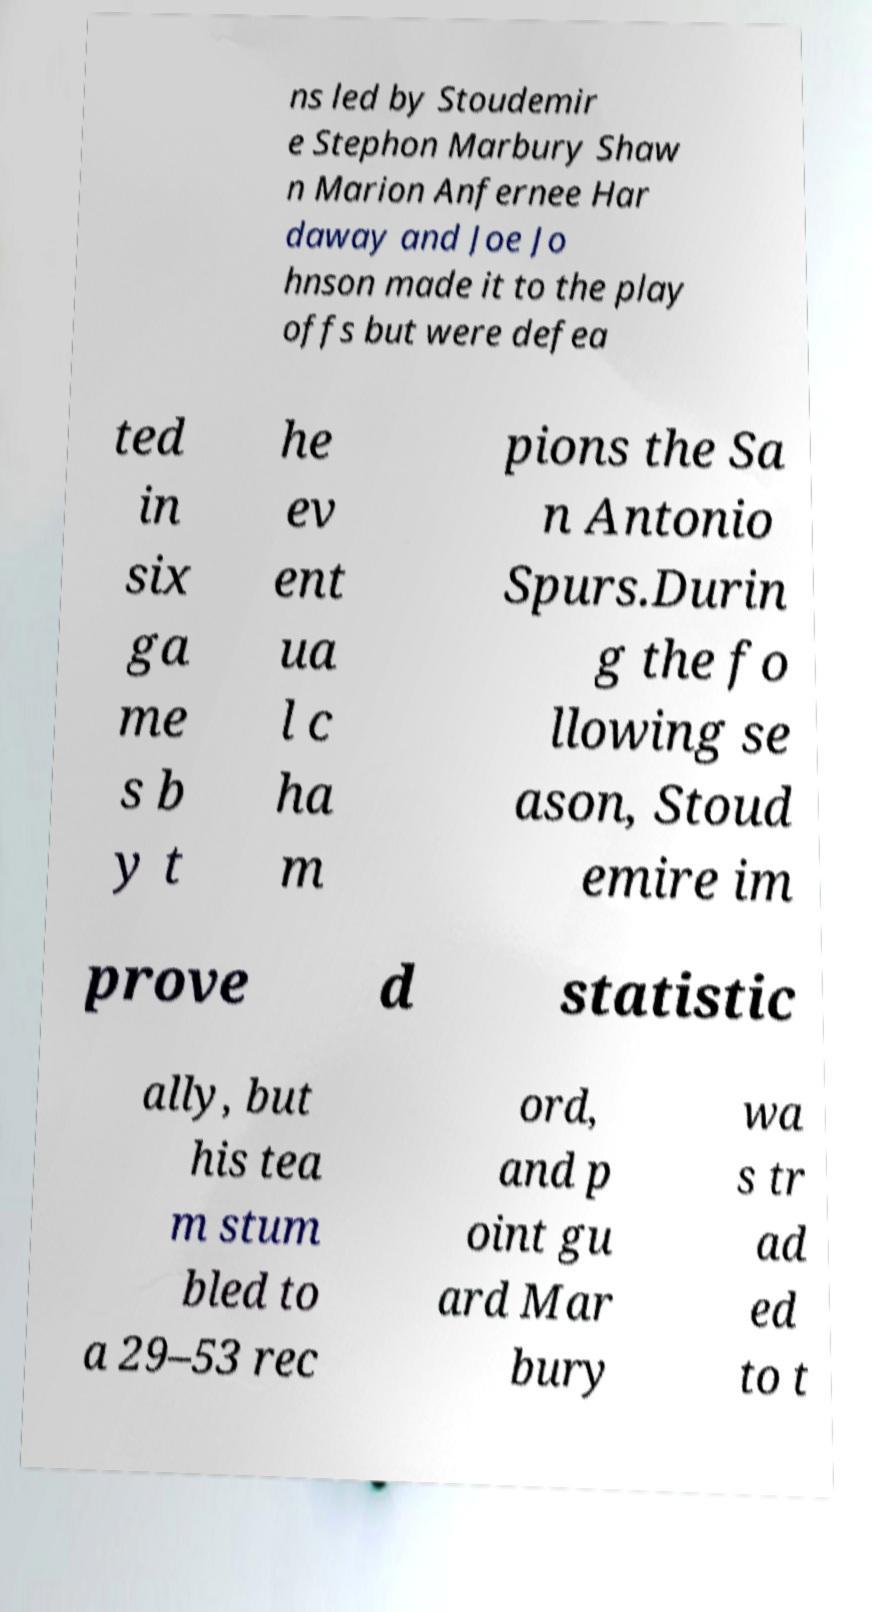I need the written content from this picture converted into text. Can you do that? ns led by Stoudemir e Stephon Marbury Shaw n Marion Anfernee Har daway and Joe Jo hnson made it to the play offs but were defea ted in six ga me s b y t he ev ent ua l c ha m pions the Sa n Antonio Spurs.Durin g the fo llowing se ason, Stoud emire im prove d statistic ally, but his tea m stum bled to a 29–53 rec ord, and p oint gu ard Mar bury wa s tr ad ed to t 